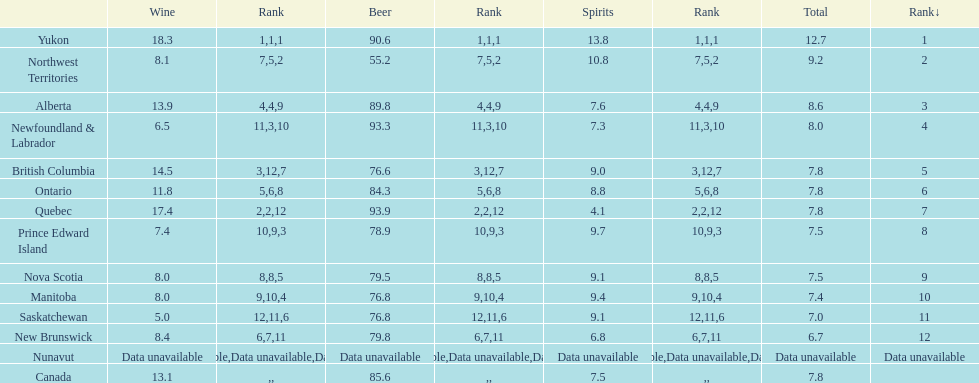0? 5. 